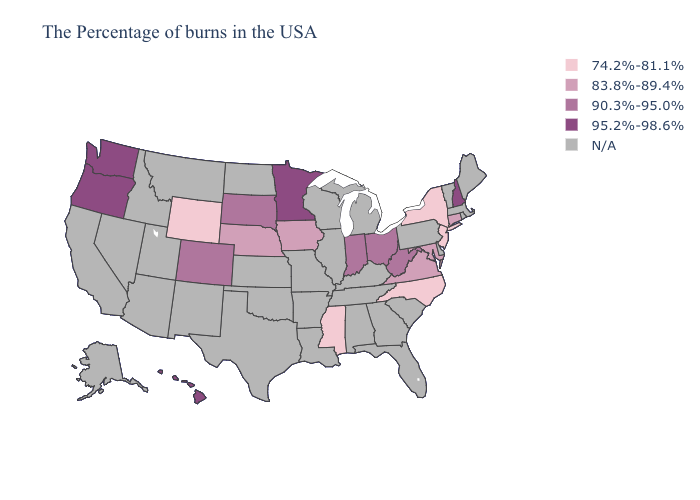Does Wyoming have the lowest value in the USA?
Answer briefly. Yes. Does Ohio have the lowest value in the USA?
Be succinct. No. Which states have the lowest value in the MidWest?
Write a very short answer. Iowa, Nebraska. Name the states that have a value in the range 90.3%-95.0%?
Concise answer only. West Virginia, Ohio, Indiana, South Dakota, Colorado. Name the states that have a value in the range 74.2%-81.1%?
Write a very short answer. New York, New Jersey, North Carolina, Mississippi, Wyoming. What is the value of Virginia?
Write a very short answer. 83.8%-89.4%. Name the states that have a value in the range 90.3%-95.0%?
Concise answer only. West Virginia, Ohio, Indiana, South Dakota, Colorado. What is the value of Arizona?
Quick response, please. N/A. What is the highest value in states that border Utah?
Short answer required. 90.3%-95.0%. Does Mississippi have the lowest value in the USA?
Concise answer only. Yes. Name the states that have a value in the range N/A?
Concise answer only. Maine, Massachusetts, Rhode Island, Vermont, Delaware, Pennsylvania, South Carolina, Florida, Georgia, Michigan, Kentucky, Alabama, Tennessee, Wisconsin, Illinois, Louisiana, Missouri, Arkansas, Kansas, Oklahoma, Texas, North Dakota, New Mexico, Utah, Montana, Arizona, Idaho, Nevada, California, Alaska. 